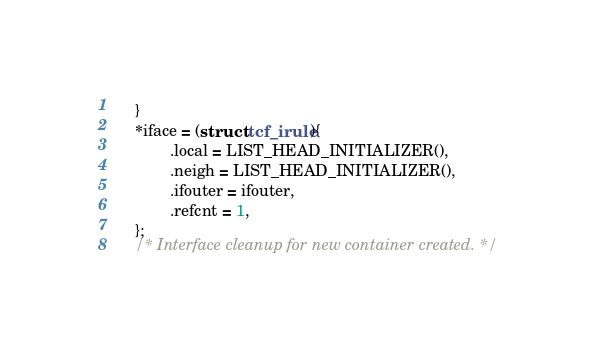<code> <loc_0><loc_0><loc_500><loc_500><_C_>	}
	*iface = (struct tcf_irule){
			.local = LIST_HEAD_INITIALIZER(),
			.neigh = LIST_HEAD_INITIALIZER(),
			.ifouter = ifouter,
			.refcnt = 1,
	};
	/* Interface cleanup for new container created. */</code> 